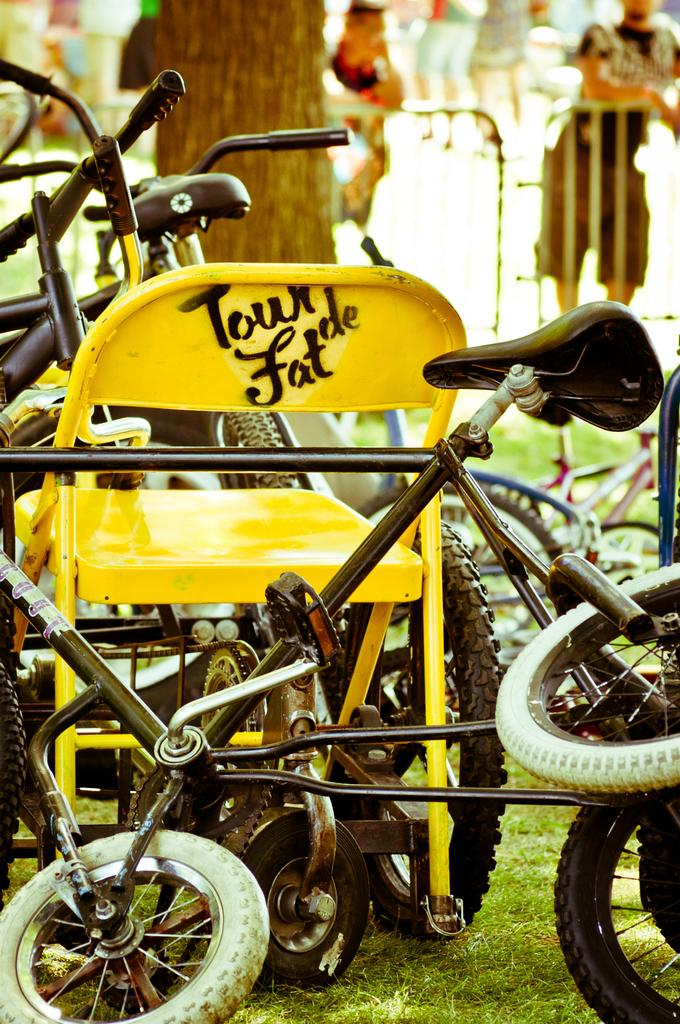What type of vehicles are present in the image? There are cycles in the image. Where are the cycles located in relation to the tree? The cycles are kept in front of a tree. Can you describe the tree's position in the image? The tree is on the ground. How is the background of the tree depicted in the image? The background of the tree is blurred. How many fingers does the tree have in the image? Trees do not have fingers, as they are plants and not human beings. 